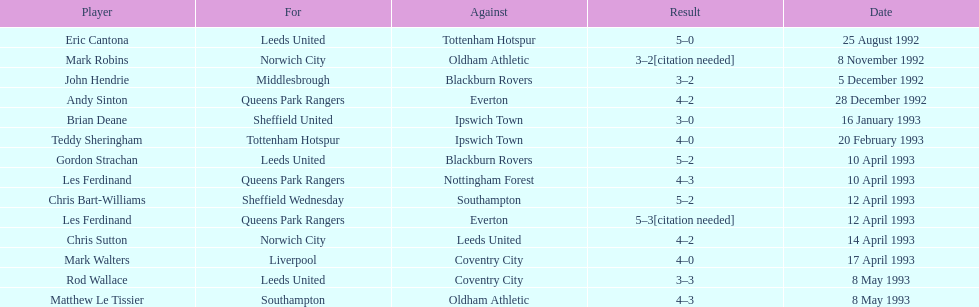Southampton played on may 8th, 1993, who was their opponent? Oldham Athletic. 